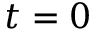Convert formula to latex. <formula><loc_0><loc_0><loc_500><loc_500>t = 0</formula> 